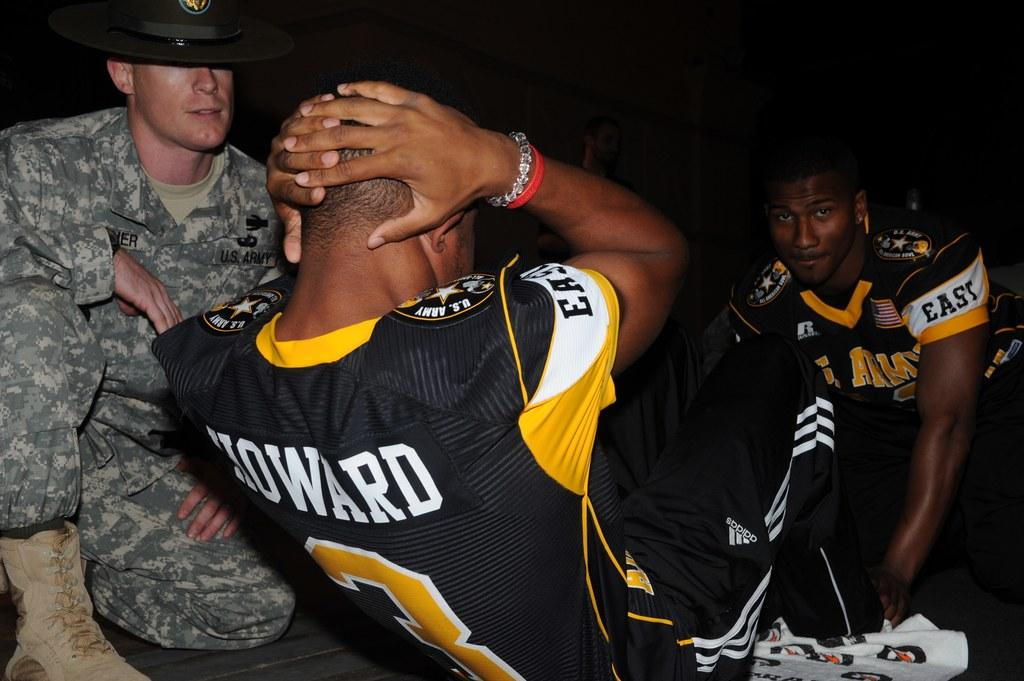<image>
Create a compact narrative representing the image presented. One of the guys in the picture is wearing a Howard jersey. 